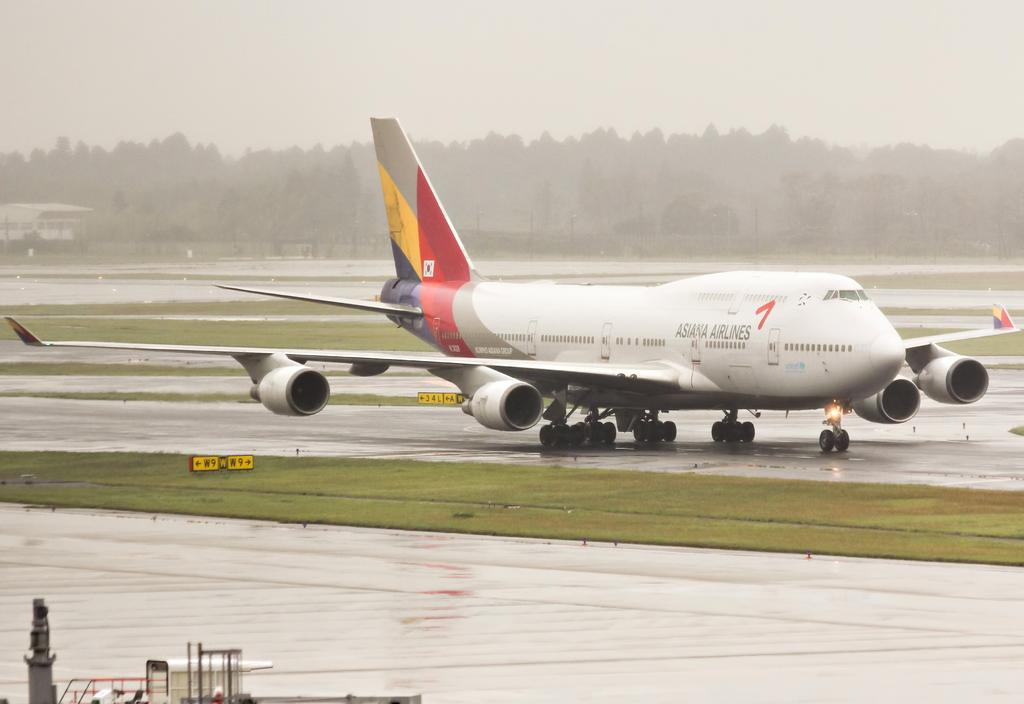Provide a one-sentence caption for the provided image. A big plane from Asiana Airlines sits on a wet runway. 